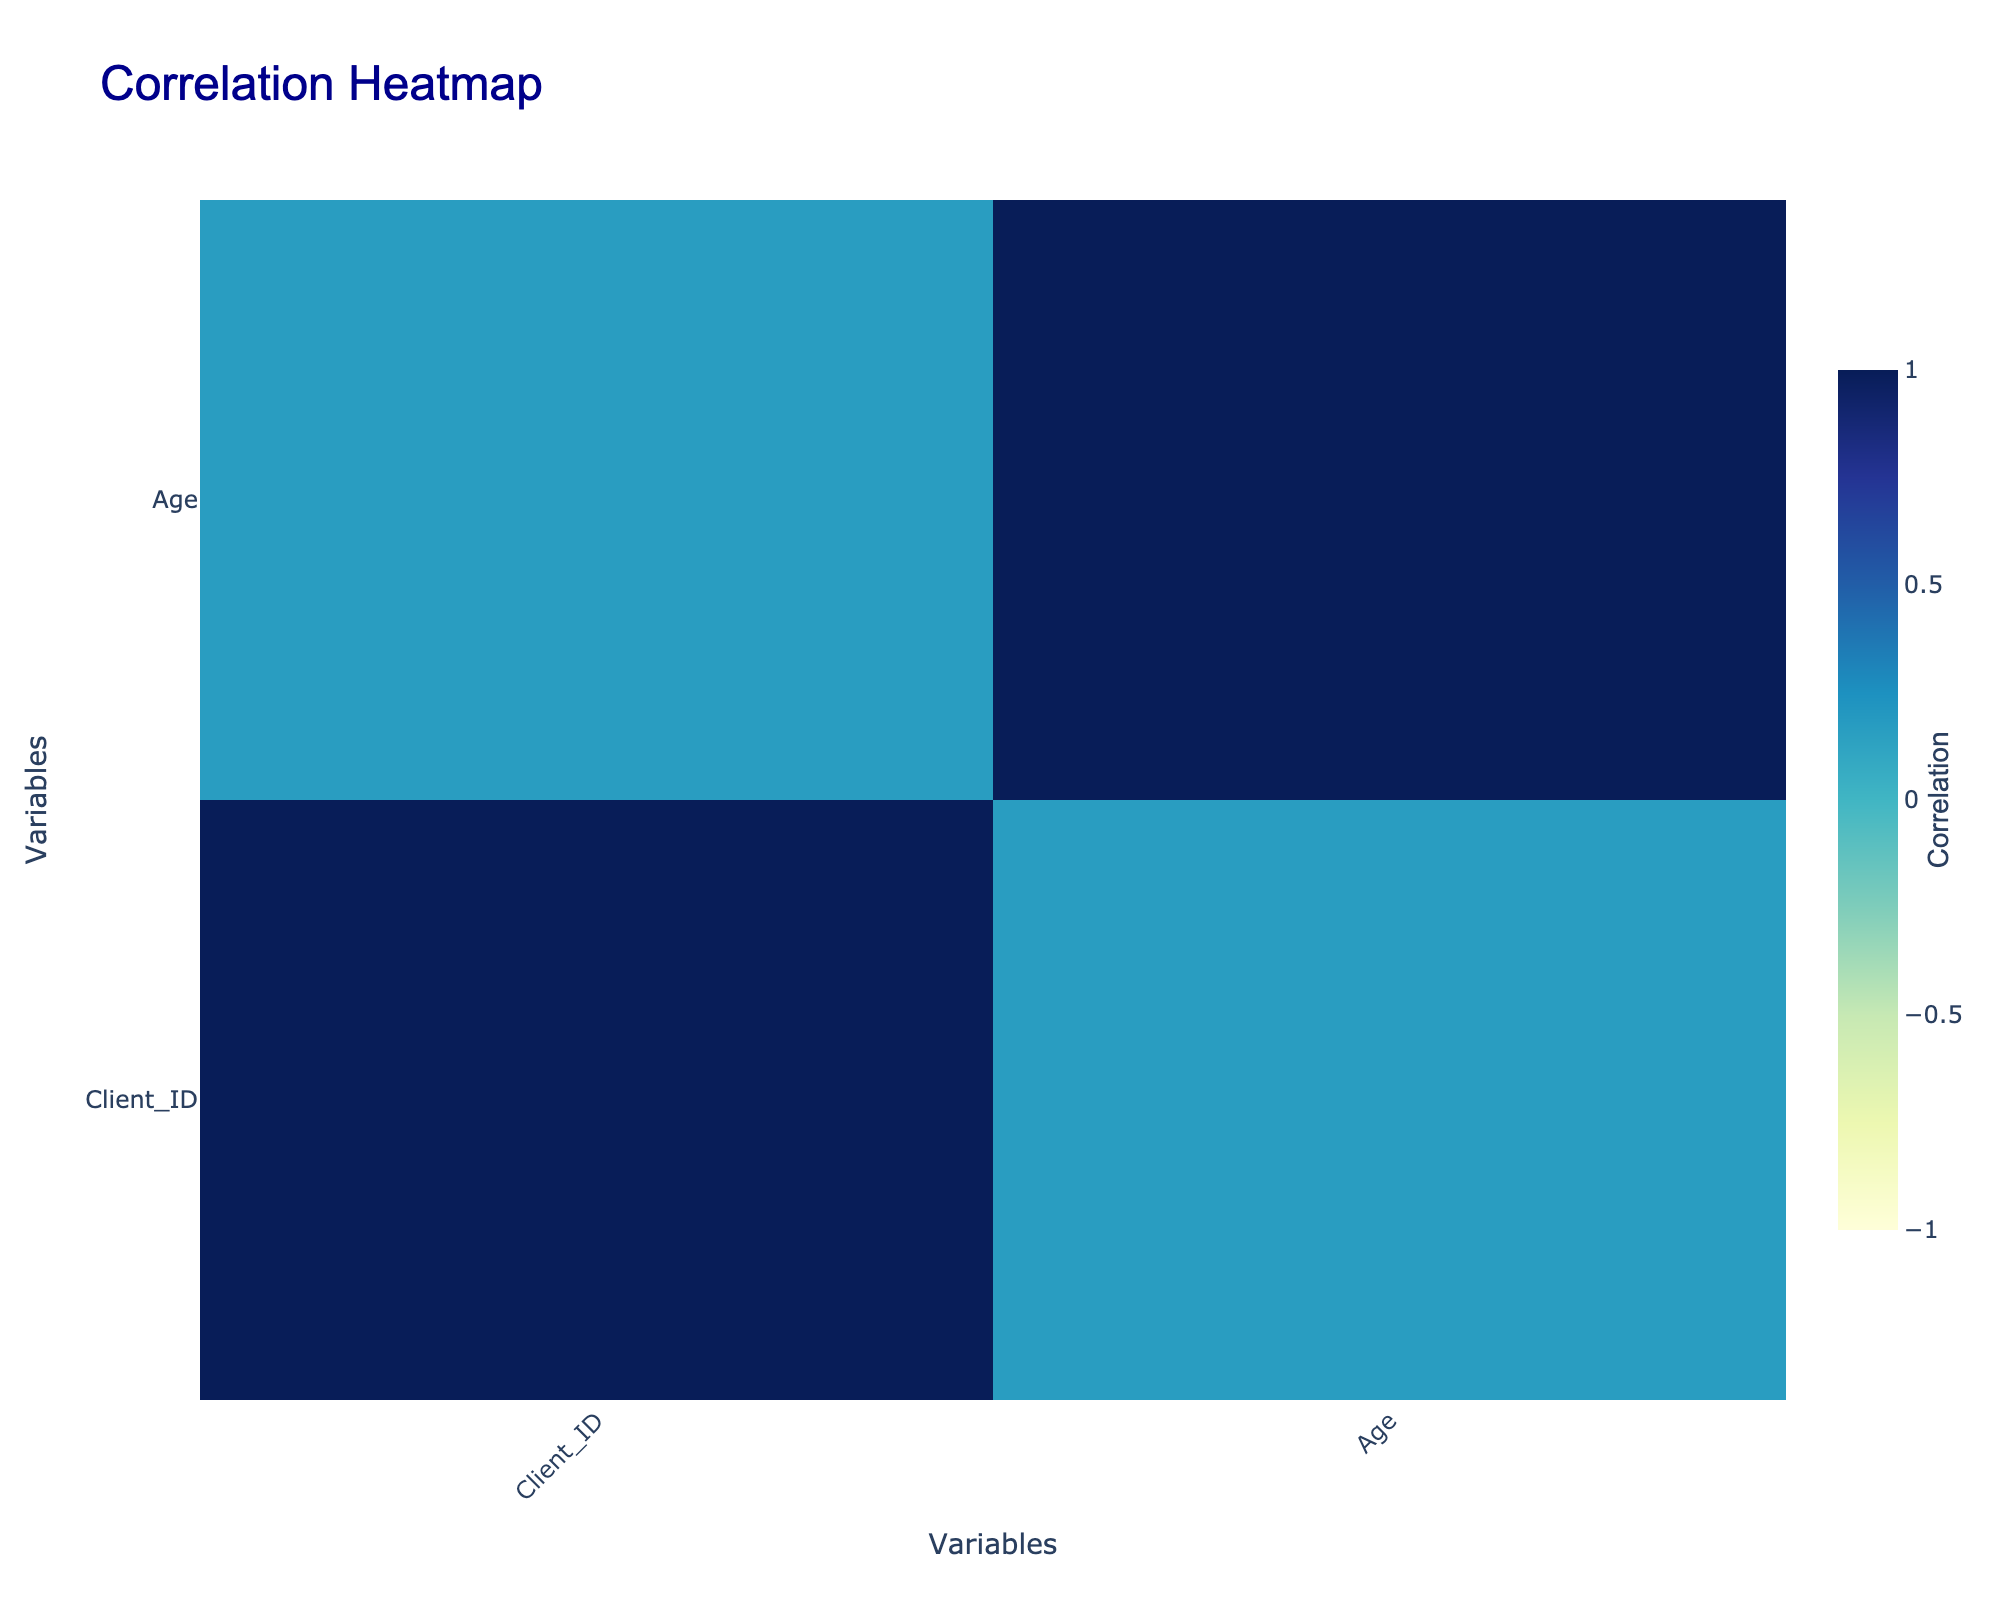What is the most common preferred reflexology technique among the clients? By reviewing the data, "Swedish Reflexology" appears three times (Client IDs 1, 4, and 10), while "Targeted Reflexology" and "Deep Tissue Reflexology" appear two times each. Therefore, the most frequent technique is "Swedish Reflexology."
Answer: Swedish Reflexology How many clients prefer reflexology for foot focus? Looking through the focus areas, there are five clients who have selected "Feet" as their focus area (Client IDs 1, 3, 5, 6, and 10). Counting these, we find 5 clients prefer this focus.
Answer: 5 Is there any correlation between age and session frequency? To determine this, we would look at the correlation values between the "Age" and "Session Frequency" columns in the correlation table. If the value is close to 1 or -1, it indicates a strong correlation.
Answer: Yes What is the average age of clients who prefer Deep Tissue Reflexology? From the data, the clients who prefer "Deep Tissue Reflexology" are Clients 3, 6, and 9. Their ages are 34, 37, and 31 respectively. Summing these gives (34 + 37 + 31) = 102, and dividing by 3 (the number of clients) gives an average age of 102/3 = 34.
Answer: 34 Is there a client who has a health issue of both anxiety and muscle tension? By checking the health issues of each client, we see Client 1 has "Anxiety," and Client 7 has "Muscle Tension." No single client has both these issues listed. Therefore, the answer is no.
Answer: No How many different occupations are represented among clients who prefer Swedish Reflexology? The clients preferring "Swedish Reflexology" are Clients 1, 4, and 10, whose occupations are Teacher, Accountant, and Scientist, respectively. Thus, there are three distinct occupations represented.
Answer: 3 Are more female clients preferring reflexology for hands compared to male clients? Referring to the data, Clients 4 and 7 prefer "Hands," where Client 4 is female and Client 7 is male. There is one female and one male client preferring reflexology for hands, so the answer in terms of comparison is equal.
Answer: No What is the most common health issue among clients who prefer feet focus? Analyzing the health issues of clients focusing on "Feet," we have Clients 1 (Anxiety), 3 (Migraine), 5 (Stress Relief), 6 (Joint Pain), and 10 (Fibromyalgia). Each health issue is unique. Thus, no single health issue is the most common.
Answer: No common issue 